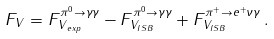<formula> <loc_0><loc_0><loc_500><loc_500>F _ { V } = F ^ { \pi ^ { 0 } \to \gamma \gamma } _ { V _ { \, e x p } } - F ^ { \pi ^ { 0 } \to \gamma \gamma } _ { V _ { I S B } } + F ^ { \pi ^ { + } \to e ^ { + } \nu \gamma } _ { V _ { I S B } } \, .</formula> 